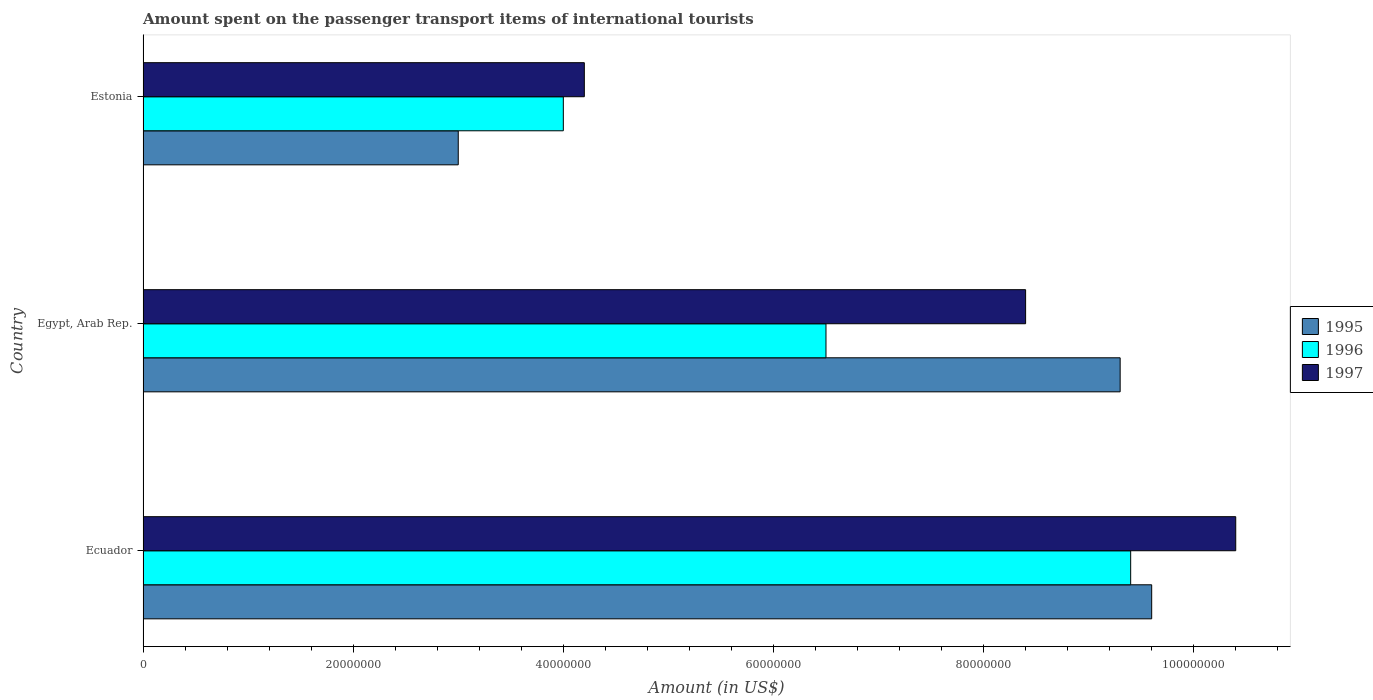Are the number of bars on each tick of the Y-axis equal?
Your response must be concise. Yes. How many bars are there on the 3rd tick from the top?
Your answer should be compact. 3. How many bars are there on the 3rd tick from the bottom?
Give a very brief answer. 3. What is the label of the 1st group of bars from the top?
Keep it short and to the point. Estonia. What is the amount spent on the passenger transport items of international tourists in 1996 in Estonia?
Provide a succinct answer. 4.00e+07. Across all countries, what is the maximum amount spent on the passenger transport items of international tourists in 1996?
Keep it short and to the point. 9.40e+07. Across all countries, what is the minimum amount spent on the passenger transport items of international tourists in 1996?
Give a very brief answer. 4.00e+07. In which country was the amount spent on the passenger transport items of international tourists in 1996 maximum?
Make the answer very short. Ecuador. In which country was the amount spent on the passenger transport items of international tourists in 1995 minimum?
Give a very brief answer. Estonia. What is the total amount spent on the passenger transport items of international tourists in 1997 in the graph?
Offer a very short reply. 2.30e+08. What is the difference between the amount spent on the passenger transport items of international tourists in 1996 in Ecuador and that in Estonia?
Provide a short and direct response. 5.40e+07. What is the difference between the amount spent on the passenger transport items of international tourists in 1996 in Egypt, Arab Rep. and the amount spent on the passenger transport items of international tourists in 1995 in Ecuador?
Provide a succinct answer. -3.10e+07. What is the average amount spent on the passenger transport items of international tourists in 1997 per country?
Your response must be concise. 7.67e+07. What is the difference between the amount spent on the passenger transport items of international tourists in 1997 and amount spent on the passenger transport items of international tourists in 1996 in Ecuador?
Offer a terse response. 1.00e+07. In how many countries, is the amount spent on the passenger transport items of international tourists in 1995 greater than 104000000 US$?
Make the answer very short. 0. What is the ratio of the amount spent on the passenger transport items of international tourists in 1996 in Ecuador to that in Egypt, Arab Rep.?
Your response must be concise. 1.45. Is the amount spent on the passenger transport items of international tourists in 1997 in Ecuador less than that in Estonia?
Provide a short and direct response. No. What is the difference between the highest and the second highest amount spent on the passenger transport items of international tourists in 1997?
Offer a very short reply. 2.00e+07. What is the difference between the highest and the lowest amount spent on the passenger transport items of international tourists in 1995?
Keep it short and to the point. 6.60e+07. What does the 3rd bar from the top in Egypt, Arab Rep. represents?
Offer a very short reply. 1995. How many bars are there?
Keep it short and to the point. 9. Are all the bars in the graph horizontal?
Give a very brief answer. Yes. Does the graph contain grids?
Your answer should be compact. No. Where does the legend appear in the graph?
Make the answer very short. Center right. How many legend labels are there?
Give a very brief answer. 3. What is the title of the graph?
Offer a terse response. Amount spent on the passenger transport items of international tourists. Does "1965" appear as one of the legend labels in the graph?
Offer a terse response. No. What is the label or title of the X-axis?
Keep it short and to the point. Amount (in US$). What is the label or title of the Y-axis?
Provide a succinct answer. Country. What is the Amount (in US$) in 1995 in Ecuador?
Make the answer very short. 9.60e+07. What is the Amount (in US$) in 1996 in Ecuador?
Give a very brief answer. 9.40e+07. What is the Amount (in US$) of 1997 in Ecuador?
Give a very brief answer. 1.04e+08. What is the Amount (in US$) in 1995 in Egypt, Arab Rep.?
Ensure brevity in your answer.  9.30e+07. What is the Amount (in US$) of 1996 in Egypt, Arab Rep.?
Ensure brevity in your answer.  6.50e+07. What is the Amount (in US$) of 1997 in Egypt, Arab Rep.?
Your answer should be compact. 8.40e+07. What is the Amount (in US$) in 1995 in Estonia?
Provide a short and direct response. 3.00e+07. What is the Amount (in US$) of 1996 in Estonia?
Your answer should be compact. 4.00e+07. What is the Amount (in US$) of 1997 in Estonia?
Your answer should be very brief. 4.20e+07. Across all countries, what is the maximum Amount (in US$) in 1995?
Ensure brevity in your answer.  9.60e+07. Across all countries, what is the maximum Amount (in US$) of 1996?
Offer a very short reply. 9.40e+07. Across all countries, what is the maximum Amount (in US$) of 1997?
Keep it short and to the point. 1.04e+08. Across all countries, what is the minimum Amount (in US$) in 1995?
Your response must be concise. 3.00e+07. Across all countries, what is the minimum Amount (in US$) in 1996?
Provide a succinct answer. 4.00e+07. Across all countries, what is the minimum Amount (in US$) of 1997?
Your answer should be very brief. 4.20e+07. What is the total Amount (in US$) of 1995 in the graph?
Offer a terse response. 2.19e+08. What is the total Amount (in US$) of 1996 in the graph?
Offer a very short reply. 1.99e+08. What is the total Amount (in US$) in 1997 in the graph?
Your answer should be compact. 2.30e+08. What is the difference between the Amount (in US$) in 1996 in Ecuador and that in Egypt, Arab Rep.?
Provide a succinct answer. 2.90e+07. What is the difference between the Amount (in US$) of 1997 in Ecuador and that in Egypt, Arab Rep.?
Your answer should be compact. 2.00e+07. What is the difference between the Amount (in US$) of 1995 in Ecuador and that in Estonia?
Your answer should be compact. 6.60e+07. What is the difference between the Amount (in US$) of 1996 in Ecuador and that in Estonia?
Give a very brief answer. 5.40e+07. What is the difference between the Amount (in US$) of 1997 in Ecuador and that in Estonia?
Offer a very short reply. 6.20e+07. What is the difference between the Amount (in US$) in 1995 in Egypt, Arab Rep. and that in Estonia?
Ensure brevity in your answer.  6.30e+07. What is the difference between the Amount (in US$) in 1996 in Egypt, Arab Rep. and that in Estonia?
Keep it short and to the point. 2.50e+07. What is the difference between the Amount (in US$) in 1997 in Egypt, Arab Rep. and that in Estonia?
Keep it short and to the point. 4.20e+07. What is the difference between the Amount (in US$) in 1995 in Ecuador and the Amount (in US$) in 1996 in Egypt, Arab Rep.?
Provide a short and direct response. 3.10e+07. What is the difference between the Amount (in US$) of 1995 in Ecuador and the Amount (in US$) of 1997 in Egypt, Arab Rep.?
Ensure brevity in your answer.  1.20e+07. What is the difference between the Amount (in US$) of 1995 in Ecuador and the Amount (in US$) of 1996 in Estonia?
Make the answer very short. 5.60e+07. What is the difference between the Amount (in US$) in 1995 in Ecuador and the Amount (in US$) in 1997 in Estonia?
Ensure brevity in your answer.  5.40e+07. What is the difference between the Amount (in US$) in 1996 in Ecuador and the Amount (in US$) in 1997 in Estonia?
Your answer should be very brief. 5.20e+07. What is the difference between the Amount (in US$) in 1995 in Egypt, Arab Rep. and the Amount (in US$) in 1996 in Estonia?
Offer a terse response. 5.30e+07. What is the difference between the Amount (in US$) in 1995 in Egypt, Arab Rep. and the Amount (in US$) in 1997 in Estonia?
Provide a short and direct response. 5.10e+07. What is the difference between the Amount (in US$) of 1996 in Egypt, Arab Rep. and the Amount (in US$) of 1997 in Estonia?
Your response must be concise. 2.30e+07. What is the average Amount (in US$) of 1995 per country?
Provide a short and direct response. 7.30e+07. What is the average Amount (in US$) in 1996 per country?
Your answer should be compact. 6.63e+07. What is the average Amount (in US$) of 1997 per country?
Give a very brief answer. 7.67e+07. What is the difference between the Amount (in US$) of 1995 and Amount (in US$) of 1996 in Ecuador?
Give a very brief answer. 2.00e+06. What is the difference between the Amount (in US$) in 1995 and Amount (in US$) in 1997 in Ecuador?
Make the answer very short. -8.00e+06. What is the difference between the Amount (in US$) in 1996 and Amount (in US$) in 1997 in Ecuador?
Offer a terse response. -1.00e+07. What is the difference between the Amount (in US$) in 1995 and Amount (in US$) in 1996 in Egypt, Arab Rep.?
Your answer should be very brief. 2.80e+07. What is the difference between the Amount (in US$) of 1995 and Amount (in US$) of 1997 in Egypt, Arab Rep.?
Give a very brief answer. 9.00e+06. What is the difference between the Amount (in US$) of 1996 and Amount (in US$) of 1997 in Egypt, Arab Rep.?
Your answer should be compact. -1.90e+07. What is the difference between the Amount (in US$) of 1995 and Amount (in US$) of 1996 in Estonia?
Provide a succinct answer. -1.00e+07. What is the difference between the Amount (in US$) of 1995 and Amount (in US$) of 1997 in Estonia?
Your answer should be very brief. -1.20e+07. What is the ratio of the Amount (in US$) in 1995 in Ecuador to that in Egypt, Arab Rep.?
Ensure brevity in your answer.  1.03. What is the ratio of the Amount (in US$) of 1996 in Ecuador to that in Egypt, Arab Rep.?
Your answer should be compact. 1.45. What is the ratio of the Amount (in US$) in 1997 in Ecuador to that in Egypt, Arab Rep.?
Offer a terse response. 1.24. What is the ratio of the Amount (in US$) in 1996 in Ecuador to that in Estonia?
Ensure brevity in your answer.  2.35. What is the ratio of the Amount (in US$) of 1997 in Ecuador to that in Estonia?
Make the answer very short. 2.48. What is the ratio of the Amount (in US$) in 1995 in Egypt, Arab Rep. to that in Estonia?
Give a very brief answer. 3.1. What is the ratio of the Amount (in US$) in 1996 in Egypt, Arab Rep. to that in Estonia?
Give a very brief answer. 1.62. What is the difference between the highest and the second highest Amount (in US$) of 1995?
Provide a short and direct response. 3.00e+06. What is the difference between the highest and the second highest Amount (in US$) of 1996?
Provide a short and direct response. 2.90e+07. What is the difference between the highest and the second highest Amount (in US$) of 1997?
Your answer should be compact. 2.00e+07. What is the difference between the highest and the lowest Amount (in US$) of 1995?
Offer a terse response. 6.60e+07. What is the difference between the highest and the lowest Amount (in US$) in 1996?
Provide a short and direct response. 5.40e+07. What is the difference between the highest and the lowest Amount (in US$) of 1997?
Ensure brevity in your answer.  6.20e+07. 